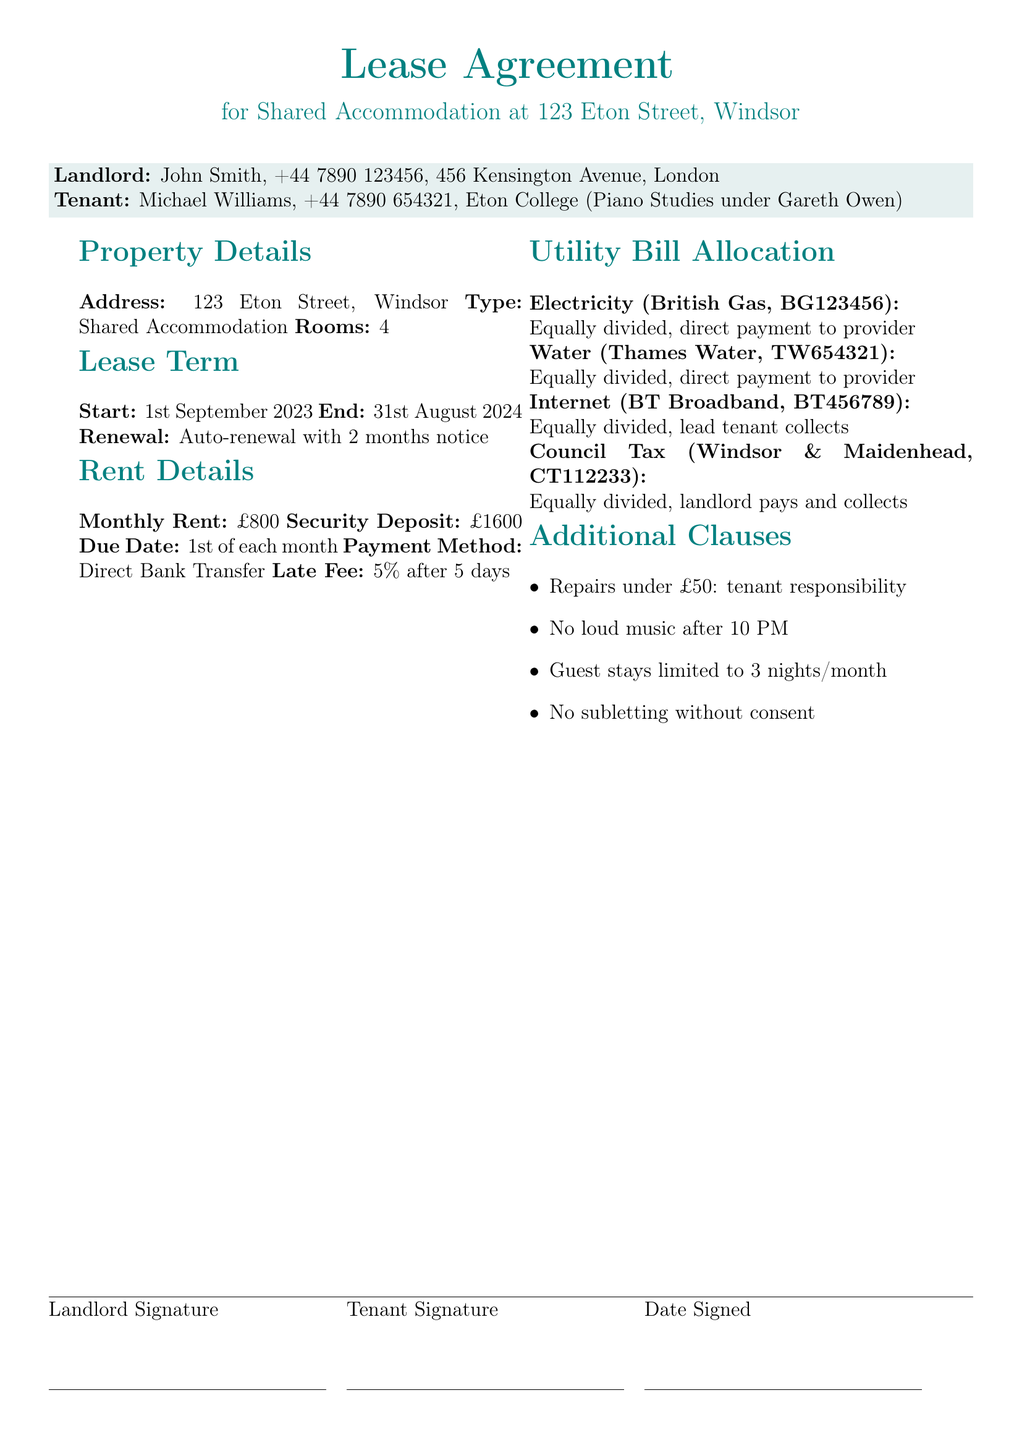what is the monthly rent? The monthly rent is stated in the Rent Details section of the document.
Answer: £800 who is the landlord? The landlord's name is listed at the beginning of the document.
Answer: John Smith what is the utility provider for water? The utility provider for water is mentioned in the Utility Bill Allocation section.
Answer: Thames Water when does the lease term end? The end date of the lease term is detailed in the Lease Term section.
Answer: 31st August 2024 how is the council tax payment managed? The management of the council tax payment is outlined in the Utility Bill Allocation section.
Answer: Landlord pays and collects what is the security deposit amount? The security deposit is specified in the Rent Details section of the document.
Answer: £1600 who is responsible for repairs under £50? The responsibility for repairs is stated in the Additional Clauses section.
Answer: Tenant responsibility what is the late fee percentage after 5 days? The late fee percentage is noted in the Rent Details section of the document.
Answer: 5% how is the internet bill paid? The payment method for the internet bill is described in the Utility Bill Allocation section.
Answer: Lead tenant collects 